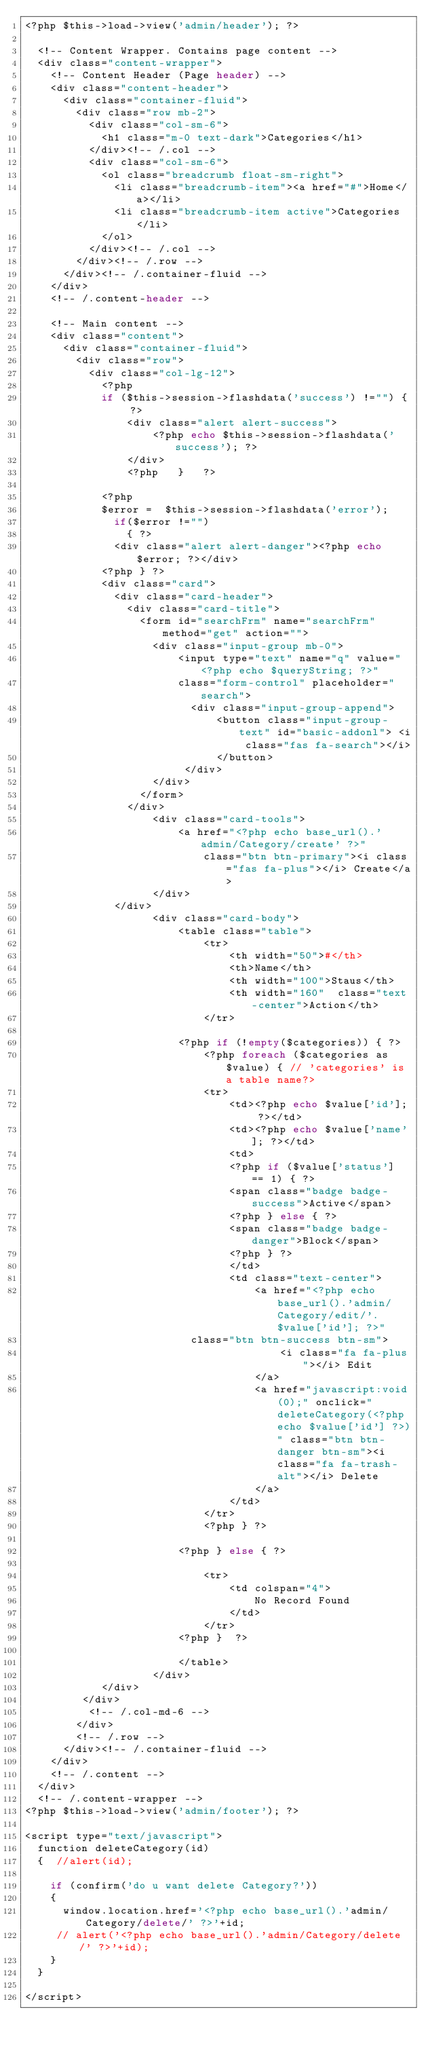<code> <loc_0><loc_0><loc_500><loc_500><_PHP_><?php $this->load->view('admin/header'); ?>

  <!-- Content Wrapper. Contains page content -->
  <div class="content-wrapper">
    <!-- Content Header (Page header) -->
    <div class="content-header">
      <div class="container-fluid">
        <div class="row mb-2">
          <div class="col-sm-6">
            <h1 class="m-0 text-dark">Categories</h1>
          </div><!-- /.col -->
          <div class="col-sm-6">
            <ol class="breadcrumb float-sm-right">
              <li class="breadcrumb-item"><a href="#">Home</a></li>
              <li class="breadcrumb-item active">Categories</li>
            </ol>
          </div><!-- /.col -->
        </div><!-- /.row -->
      </div><!-- /.container-fluid -->
    </div>
    <!-- /.content-header -->

    <!-- Main content -->
    <div class="content">
      <div class="container-fluid">
        <div class="row">
          <div class="col-lg-12">
          	<?php 
          	if ($this->session->flashdata('success') !="") { ?>
          		<div class="alert alert-success">
          			<?php echo $this->session->flashdata('success'); ?>
          		</div>
         		<?php 	}   ?>

            <?php
            $error =  $this->session->flashdata('error');
              if($error !="")
                { ?> 
              <div class="alert alert-danger"><?php echo $error; ?></div>  
            <?php } ?>
            <div class="card">
              <div class="card-header">
              	<div class="card-title">
                  <form id="searchFrm" name="searchFrm" method="get" action="">
                    <div class="input-group mb-0">
                        <input type="text" name="q" value="<?php echo $queryString; ?>" 
                        class="form-control" placeholder="search">
                          <div class="input-group-append">
                              <button class="input-group-text" id="basic-addonl"> <i class="fas fa-search"></i>
                              </button>
                         </div>
                    </div>
                  </form>
                </div>
              		<div class="card-tools">
              			<a href="<?php echo base_url().'admin/Category/create' ?>" 
              				class="btn btn-primary"><i class="fas fa-plus"></i> Create</a>
              		</div>
              </div>
              		<div class="card-body">
              			<table class="table">
              				<tr>
              					<th width="50">#</th>
              					<th>Name</th>
              					<th width="100">Staus</th>
              					<th width="160"  class="text-center">Action</th>
              				</tr>
              			
              			<?php if (!empty($categories)) { ?>
              				<?php foreach ($categories as $value) { // 'categories' is a table name?> 
              				<tr>
              					<td><?php echo $value['id']; ?></td>
              					<td><?php echo $value['name']; ?></td>
              					<td>
              					<?php if ($value['status'] == 1) { ?>
              					<span class="badge badge-success">Active</span>
              					<?php } else { ?>
              					<span class="badge badge-danger">Block</span>
              					<?php } ?>
              					</td>
              					<td class="text-center">
              						<a href="<?php echo base_url().'admin/Category/edit/'.$value['id']; ?>"
                          class="btn btn-success btn-sm">
              							<i class="fa fa-plus"></i> Edit
              						</a>
              						<a href="javascript:void(0);" onclick="deleteCategory(<?php echo $value['id'] ?>)" class="btn btn-danger btn-sm"><i class="fa fa-trash-alt"></i> Delete
              						</a>
              					</td>
              				</tr>
              				<?php } ?>

              			<?php } else { ?>

              				<tr>
              					<td colspan="4">
              						No Record Found
              					</td>
              				</tr>
              			<?php }  ?>

              			</table>
              		</div>
            </div>
         </div>
          <!-- /.col-md-6 -->
        </div>
        <!-- /.row -->
      </div><!-- /.container-fluid -->
    </div>
    <!-- /.content -->
  </div>
  <!-- /.content-wrapper -->
<?php $this->load->view('admin/footer'); ?>

<script type="text/javascript">
  function deleteCategory(id) 
  {  //alert(id);
  
    if (confirm('do u want delete Category?')) 
    {
      window.location.href='<?php echo base_url().'admin/Category/delete/' ?>'+id;
     // alert('<?php echo base_url().'admin/Category/delete/' ?>'+id);
    }
  }

</script></code> 